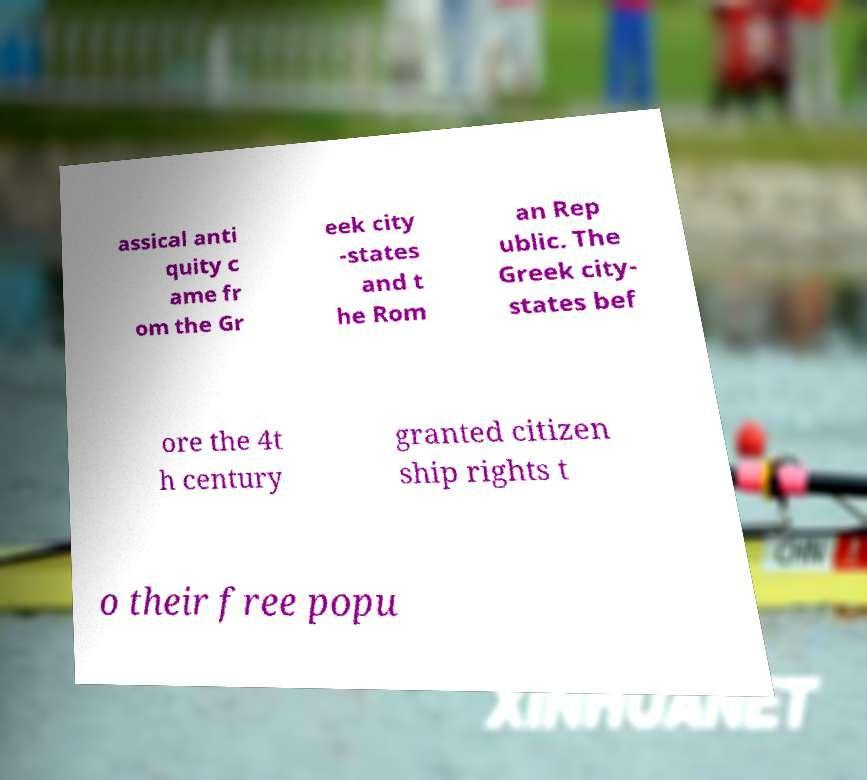Could you extract and type out the text from this image? assical anti quity c ame fr om the Gr eek city -states and t he Rom an Rep ublic. The Greek city- states bef ore the 4t h century granted citizen ship rights t o their free popu 